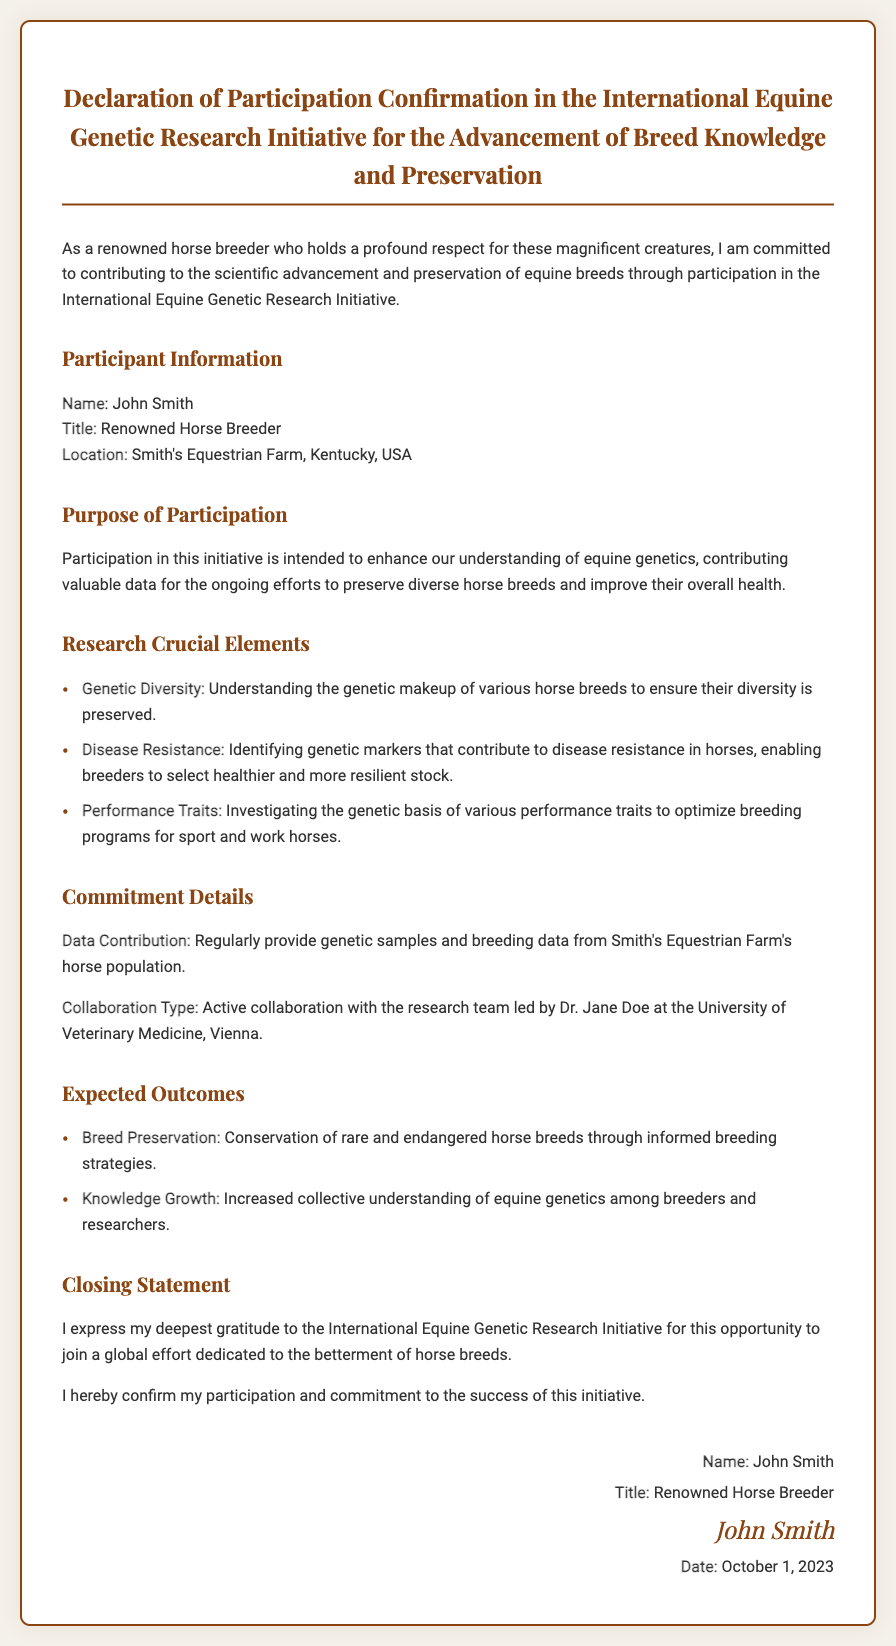What is the name of the participant? The participant's name is explicitly stated in the document.
Answer: John Smith What is the title of the participant? The title is mentioned following the participant's name in the declaration.
Answer: Renowned Horse Breeder Where is the participant located? The location is provided in the participant information section of the document.
Answer: Smith's Equestrian Farm, Kentucky, USA What is the date of the declaration? The date is listed in the signature section of the document.
Answer: October 1, 2023 What is one of the research crucial elements mentioned? The elements are categorized in a list within the document.
Answer: Genetic Diversity What type of collaboration is mentioned? This detail is stated in the commitment section regarding the nature of the collaboration.
Answer: Active collaboration What is one expected outcome of the research initiative? Expected outcomes are outlined in a list within the document.
Answer: Breed Preservation What is the purpose of participation? The purpose is described in a paragraph summarizing the intent behind joining the initiative.
Answer: Enhance understanding of equine genetics Who is leading the research team? The name of the leader of the research team is provided in the commitment section.
Answer: Dr. Jane Doe 